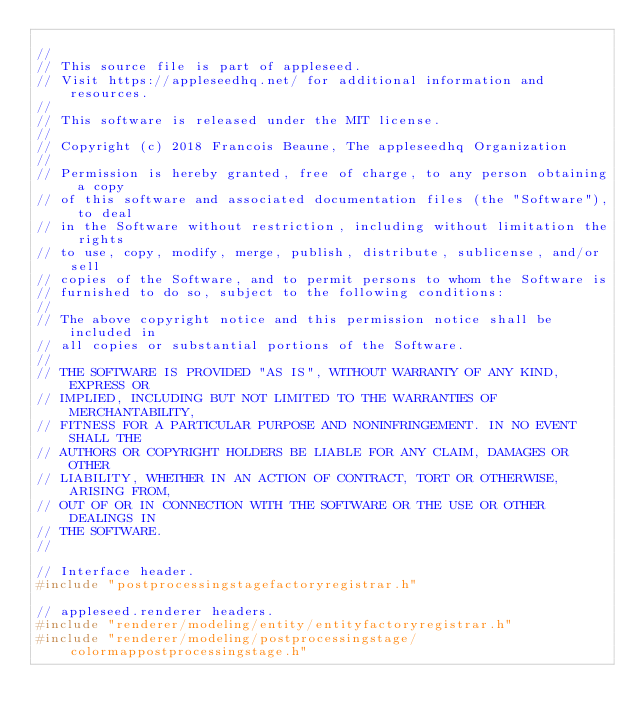Convert code to text. <code><loc_0><loc_0><loc_500><loc_500><_C++_>
//
// This source file is part of appleseed.
// Visit https://appleseedhq.net/ for additional information and resources.
//
// This software is released under the MIT license.
//
// Copyright (c) 2018 Francois Beaune, The appleseedhq Organization
//
// Permission is hereby granted, free of charge, to any person obtaining a copy
// of this software and associated documentation files (the "Software"), to deal
// in the Software without restriction, including without limitation the rights
// to use, copy, modify, merge, publish, distribute, sublicense, and/or sell
// copies of the Software, and to permit persons to whom the Software is
// furnished to do so, subject to the following conditions:
//
// The above copyright notice and this permission notice shall be included in
// all copies or substantial portions of the Software.
//
// THE SOFTWARE IS PROVIDED "AS IS", WITHOUT WARRANTY OF ANY KIND, EXPRESS OR
// IMPLIED, INCLUDING BUT NOT LIMITED TO THE WARRANTIES OF MERCHANTABILITY,
// FITNESS FOR A PARTICULAR PURPOSE AND NONINFRINGEMENT. IN NO EVENT SHALL THE
// AUTHORS OR COPYRIGHT HOLDERS BE LIABLE FOR ANY CLAIM, DAMAGES OR OTHER
// LIABILITY, WHETHER IN AN ACTION OF CONTRACT, TORT OR OTHERWISE, ARISING FROM,
// OUT OF OR IN CONNECTION WITH THE SOFTWARE OR THE USE OR OTHER DEALINGS IN
// THE SOFTWARE.
//

// Interface header.
#include "postprocessingstagefactoryregistrar.h"

// appleseed.renderer headers.
#include "renderer/modeling/entity/entityfactoryregistrar.h"
#include "renderer/modeling/postprocessingstage/colormappostprocessingstage.h"</code> 